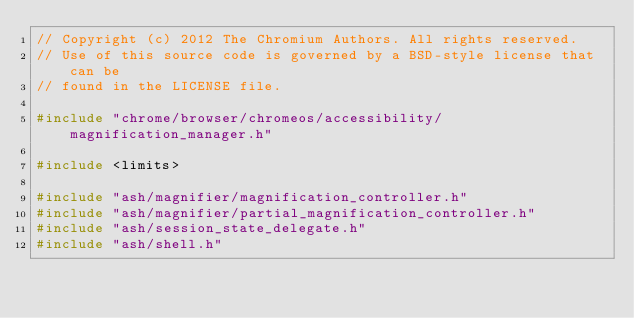<code> <loc_0><loc_0><loc_500><loc_500><_C++_>// Copyright (c) 2012 The Chromium Authors. All rights reserved.
// Use of this source code is governed by a BSD-style license that can be
// found in the LICENSE file.

#include "chrome/browser/chromeos/accessibility/magnification_manager.h"

#include <limits>

#include "ash/magnifier/magnification_controller.h"
#include "ash/magnifier/partial_magnification_controller.h"
#include "ash/session_state_delegate.h"
#include "ash/shell.h"</code> 